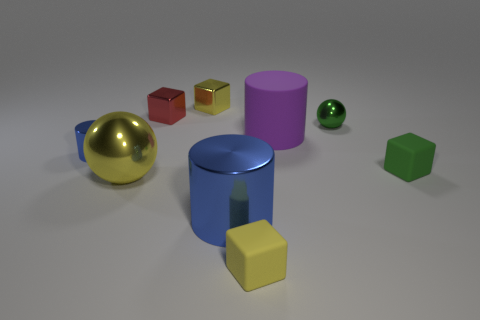Subtract 2 cubes. How many cubes are left? 2 Add 1 tiny purple balls. How many objects exist? 10 Subtract all red blocks. How many blocks are left? 3 Subtract all cyan cubes. Subtract all brown cylinders. How many cubes are left? 4 Subtract all spheres. How many objects are left? 7 Subtract 0 gray balls. How many objects are left? 9 Subtract all small blue cylinders. Subtract all tiny yellow rubber cubes. How many objects are left? 7 Add 3 small metal balls. How many small metal balls are left? 4 Add 9 small green cubes. How many small green cubes exist? 10 